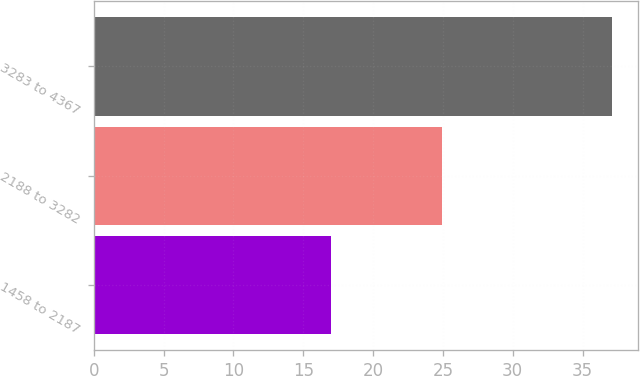Convert chart to OTSL. <chart><loc_0><loc_0><loc_500><loc_500><bar_chart><fcel>1458 to 2187<fcel>2188 to 3282<fcel>3283 to 4367<nl><fcel>16.99<fcel>24.97<fcel>37.09<nl></chart> 